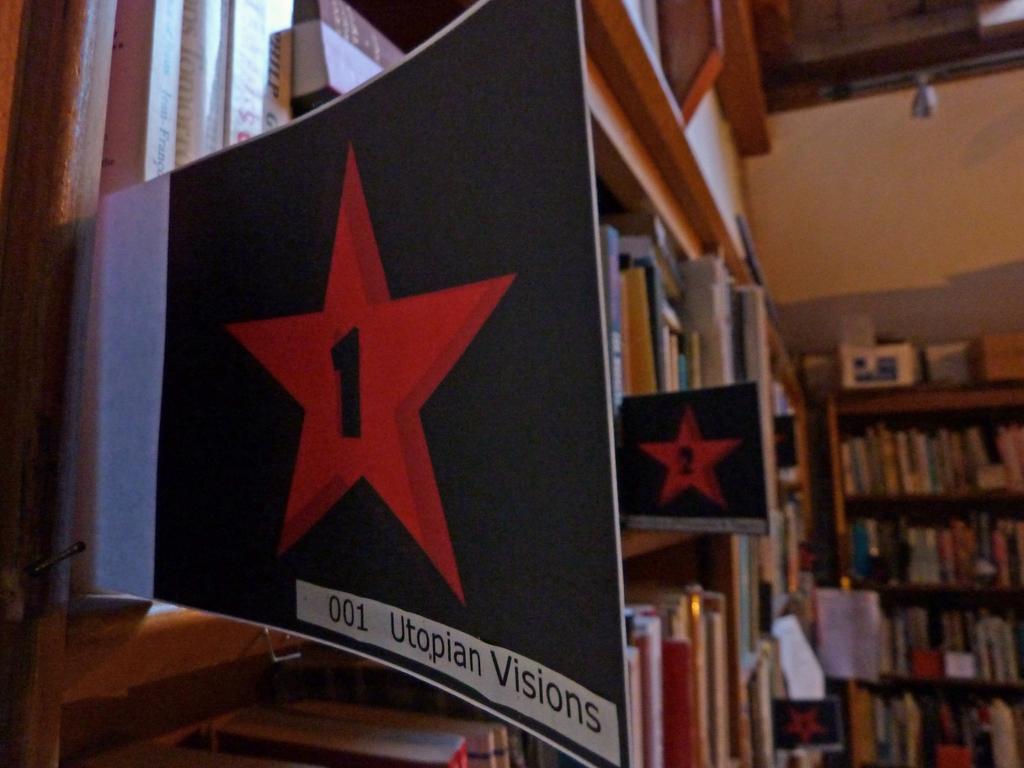What number is on the star?
Provide a succinct answer. 1. What does it say under the star?
Provide a short and direct response. 001 utopian visions. 